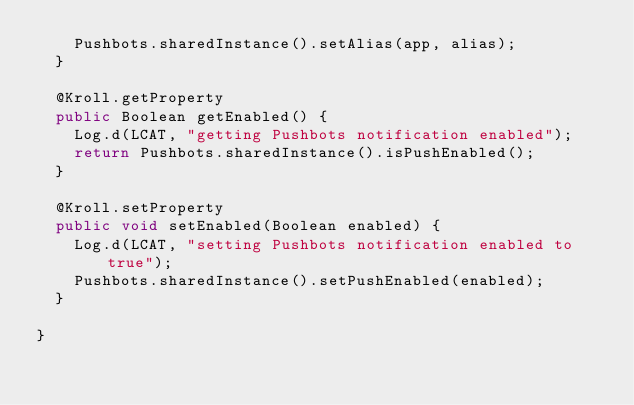<code> <loc_0><loc_0><loc_500><loc_500><_Java_>		Pushbots.sharedInstance().setAlias(app, alias);
	}

	@Kroll.getProperty
	public Boolean getEnabled() {
		Log.d(LCAT, "getting Pushbots notification enabled");
		return Pushbots.sharedInstance().isPushEnabled();
	}

	@Kroll.setProperty
	public void setEnabled(Boolean enabled) {
		Log.d(LCAT, "setting Pushbots notification enabled to true");
		Pushbots.sharedInstance().setPushEnabled(enabled);
	}

}
</code> 